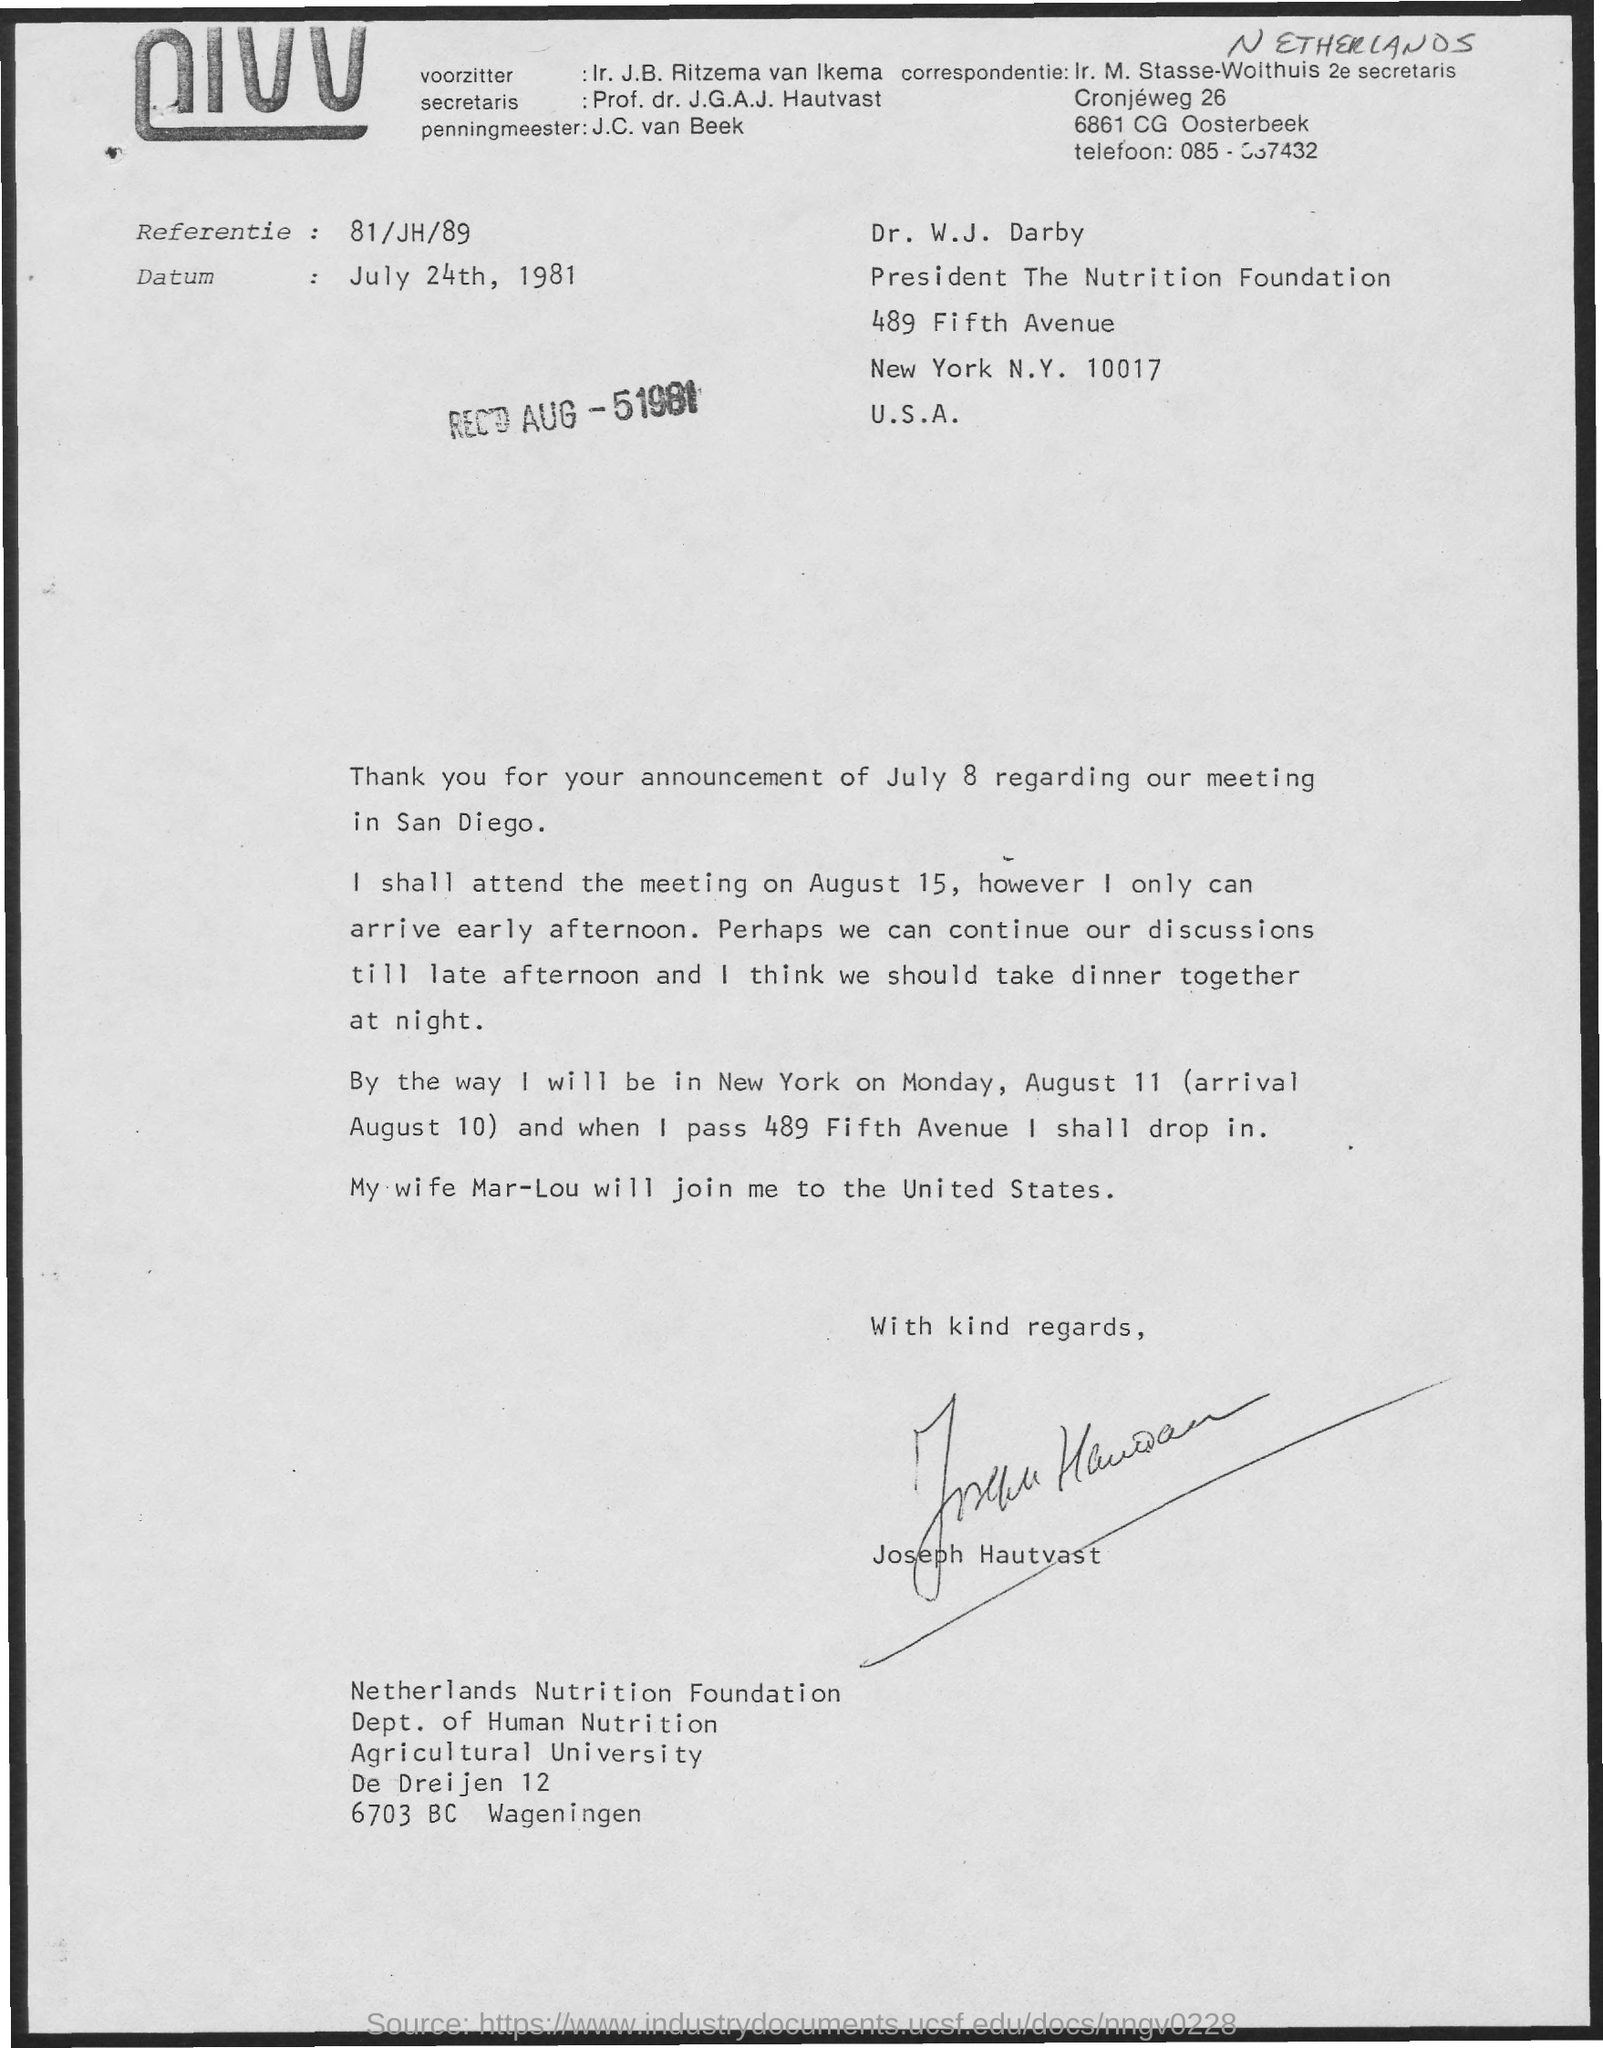When is the document dated?
Ensure brevity in your answer.  July 24th, 1981. Which foundation is Joseph Hautvast part of?
Keep it short and to the point. Netherlands Nutrition Foundation. On which date can Joseph attend the meeting?
Your answer should be very brief. August 15. Who is Joseph's wife?
Keep it short and to the point. Mar-Lou. 